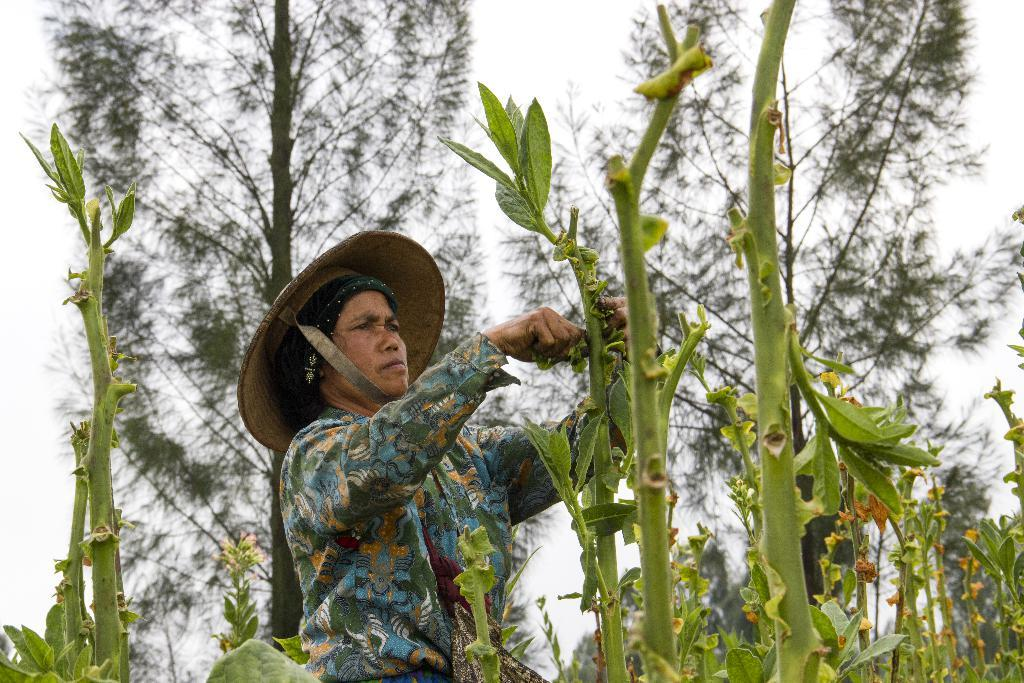What is the main subject of the image? There is a person standing in the image. What is the person holding in the image? The person is holding a tree. What can be seen in the background of the image? There are trees and the sky visible in the background of the image. How many ladybugs can be seen on the stove in the image? There is no stove or ladybugs present in the image. 